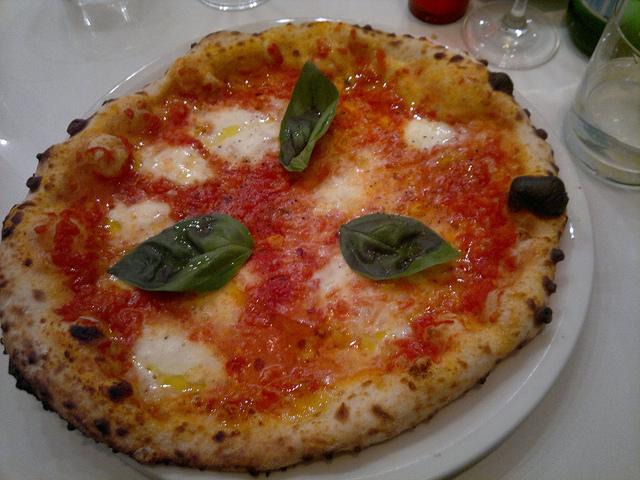Is this an extra large pizza?
Short answer required. No. Is there pepperoni on this pizza?
Answer briefly. No. What is green?
Quick response, please. Basil leaves. What snack is this?
Give a very brief answer. Pizza. Is the pizza sauce organic?
Keep it brief. Yes. What kind of food is this?
Keep it brief. Pizza. What toppings are on the pizza?
Write a very short answer. Spinach. 